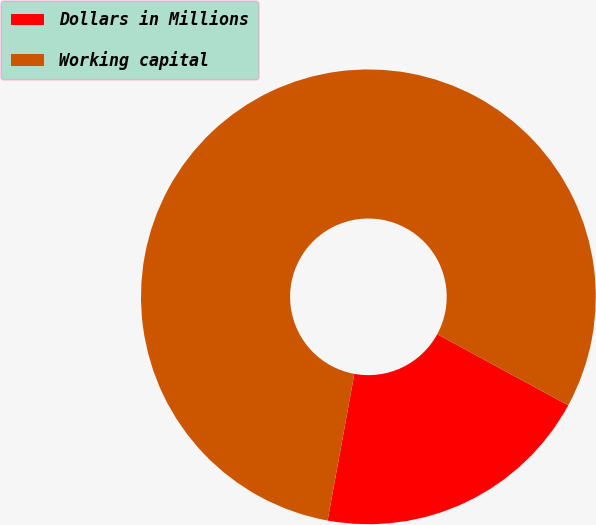Convert chart. <chart><loc_0><loc_0><loc_500><loc_500><pie_chart><fcel>Dollars in Millions<fcel>Working capital<nl><fcel>19.96%<fcel>80.04%<nl></chart> 